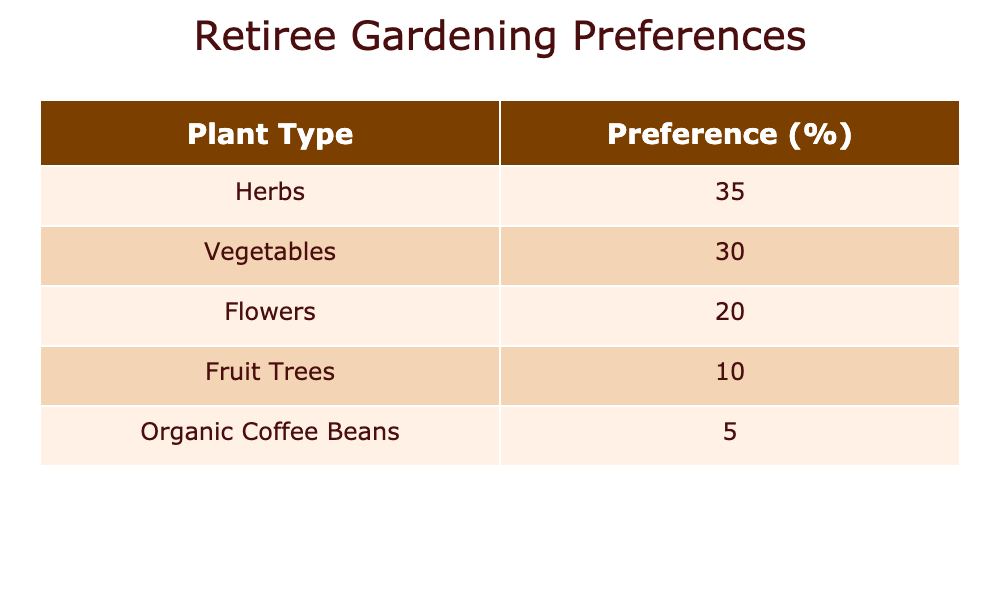What is the most preferred plant type among retirees? The table shows the "Retiree Gardening Preference" values for each plant type. The plant type with the highest preference is "Herbs" with a preference of 35.
Answer: Herbs What percentage of retirees prefer fruit trees? The table lists the 'Retiree Gardening Preference' for fruit trees as 10. Therefore, the percentage of retirees who prefer fruit trees is 10%.
Answer: 10% Is the preference for vegetables higher than that for organic coffee beans? To answer this, we compare the values in the table: vegetables have a preference of 30, while organic coffee beans have a preference of 5. Since 30 is greater than 5, the preference for vegetables is indeed higher.
Answer: Yes How many more retirees prefer herbs compared to organic coffee beans? The number of retirees who prefer herbs is 35 and for organic coffee beans, it is 5. To find the difference, subtract the latter from the former: 35 - 5 = 30.
Answer: 30 What is the total preference percentage for flowers and fruit trees combined? The preference for flowers is 20 and for fruit trees is 10. Adding these values together gives 20 + 10 = 30.
Answer: 30 Are the preferences for flowers and organic coffee beans the same? The preference for flowers is 20 and for organic coffee beans is 5. Since these numbers are not equal, the preference for flowers is not the same as that for organic coffee beans.
Answer: No What is the average preference percentage for all types of plants listed in the table? To find the average, we first sum all the preferences: 35 + 30 + 20 + 10 + 5 = 100. Then, divide by the number of plant types (5): 100/5 = 20.
Answer: 20 Which two plant types have the lowest preference percentages? According to the table, the two plant types with the lowest preferences are "Fruit Trees" at 10 and "Organic Coffee Beans" at 5. Hence, these are the lowest.
Answer: Fruit Trees, Organic Coffee Beans What is the difference in preference between herbs and flowers? From the table, herbs have a preference of 35 and flowers have a preference of 20. The difference can be found by subtracting the preference of flowers from that of herbs: 35 - 20 = 15.
Answer: 15 